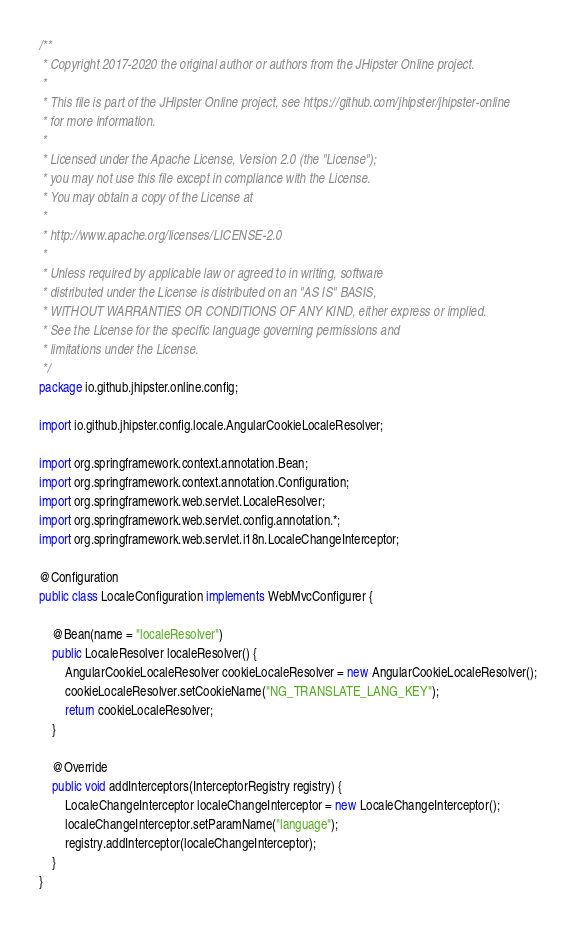Convert code to text. <code><loc_0><loc_0><loc_500><loc_500><_Java_>/**
 * Copyright 2017-2020 the original author or authors from the JHipster Online project.
 *
 * This file is part of the JHipster Online project, see https://github.com/jhipster/jhipster-online
 * for more information.
 *
 * Licensed under the Apache License, Version 2.0 (the "License");
 * you may not use this file except in compliance with the License.
 * You may obtain a copy of the License at
 *
 * http://www.apache.org/licenses/LICENSE-2.0
 *
 * Unless required by applicable law or agreed to in writing, software
 * distributed under the License is distributed on an "AS IS" BASIS,
 * WITHOUT WARRANTIES OR CONDITIONS OF ANY KIND, either express or implied.
 * See the License for the specific language governing permissions and
 * limitations under the License.
 */
package io.github.jhipster.online.config;

import io.github.jhipster.config.locale.AngularCookieLocaleResolver;

import org.springframework.context.annotation.Bean;
import org.springframework.context.annotation.Configuration;
import org.springframework.web.servlet.LocaleResolver;
import org.springframework.web.servlet.config.annotation.*;
import org.springframework.web.servlet.i18n.LocaleChangeInterceptor;

@Configuration
public class LocaleConfiguration implements WebMvcConfigurer {

    @Bean(name = "localeResolver")
    public LocaleResolver localeResolver() {
        AngularCookieLocaleResolver cookieLocaleResolver = new AngularCookieLocaleResolver();
        cookieLocaleResolver.setCookieName("NG_TRANSLATE_LANG_KEY");
        return cookieLocaleResolver;
    }

    @Override
    public void addInterceptors(InterceptorRegistry registry) {
        LocaleChangeInterceptor localeChangeInterceptor = new LocaleChangeInterceptor();
        localeChangeInterceptor.setParamName("language");
        registry.addInterceptor(localeChangeInterceptor);
    }
}
</code> 